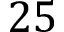<formula> <loc_0><loc_0><loc_500><loc_500>2 5</formula> 